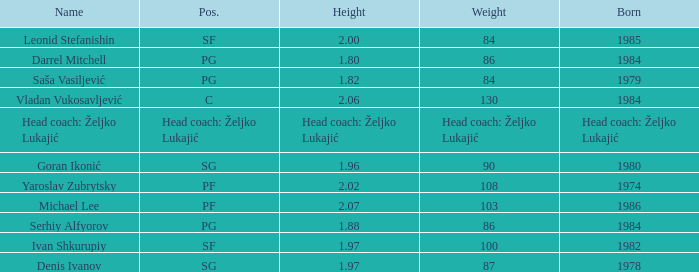What is the weight of the person born in 1980? 90.0. 